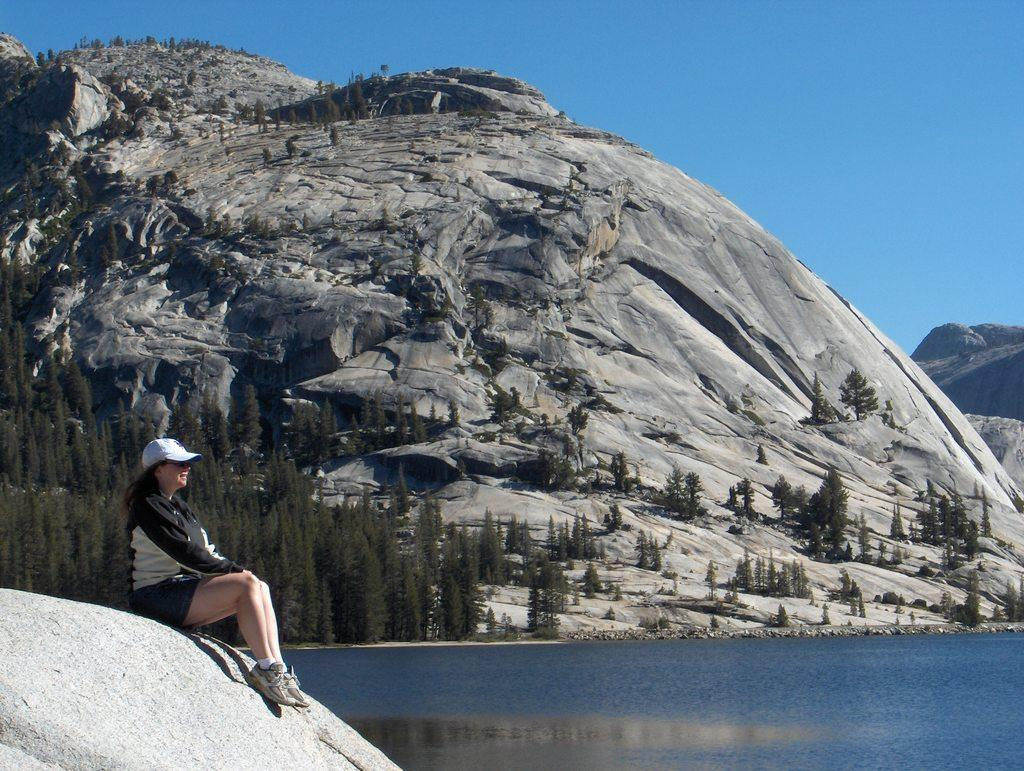What is the woman in the image doing? The woman is sitting in the image. What is the woman wearing? The woman is wearing clothes, shoes, and a cap. What can be seen in the background of the image? Mountains, trees, water, and the sky are visible in the image. How many sheep are visible on the tray in the image? There are no sheep or tray present in the image. What time of day is depicted in the image? The provided facts do not mention the time of day, so it cannot be determined from the image. 